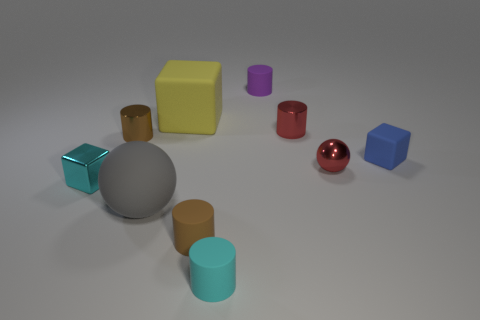There is a red object that is the same shape as the cyan rubber thing; what is it made of?
Your answer should be very brief. Metal. How many large objects are gray matte spheres or cyan objects?
Give a very brief answer. 1. Is there another red cylinder that has the same size as the red cylinder?
Offer a very short reply. No. What number of metallic objects are either small brown cylinders or large purple blocks?
Ensure brevity in your answer.  1. There is a object that is the same color as the shiny cube; what is its shape?
Keep it short and to the point. Cylinder. How many big objects are there?
Your response must be concise. 2. Does the tiny brown thing that is behind the metal sphere have the same material as the cylinder to the right of the small purple rubber cylinder?
Your answer should be very brief. Yes. What is the size of the blue block that is the same material as the large gray thing?
Keep it short and to the point. Small. There is a tiny cyan metallic thing that is in front of the shiny ball; what is its shape?
Keep it short and to the point. Cube. Is the color of the small block that is left of the cyan matte object the same as the small object that is in front of the brown matte thing?
Your answer should be compact. Yes. 